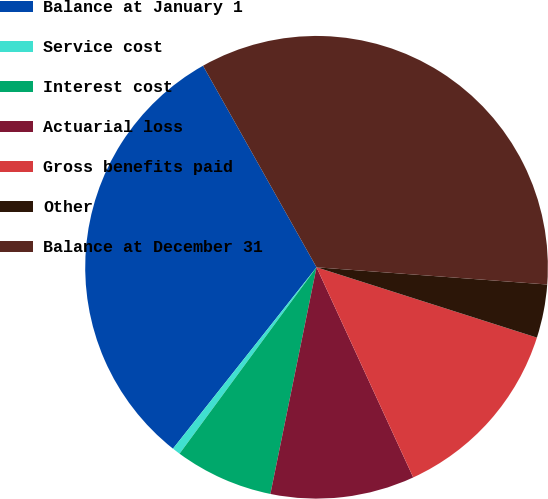Convert chart to OTSL. <chart><loc_0><loc_0><loc_500><loc_500><pie_chart><fcel>Balance at January 1<fcel>Service cost<fcel>Interest cost<fcel>Actuarial loss<fcel>Gross benefits paid<fcel>Other<fcel>Balance at December 31<nl><fcel>31.18%<fcel>0.57%<fcel>6.89%<fcel>10.06%<fcel>13.22%<fcel>3.73%<fcel>34.35%<nl></chart> 